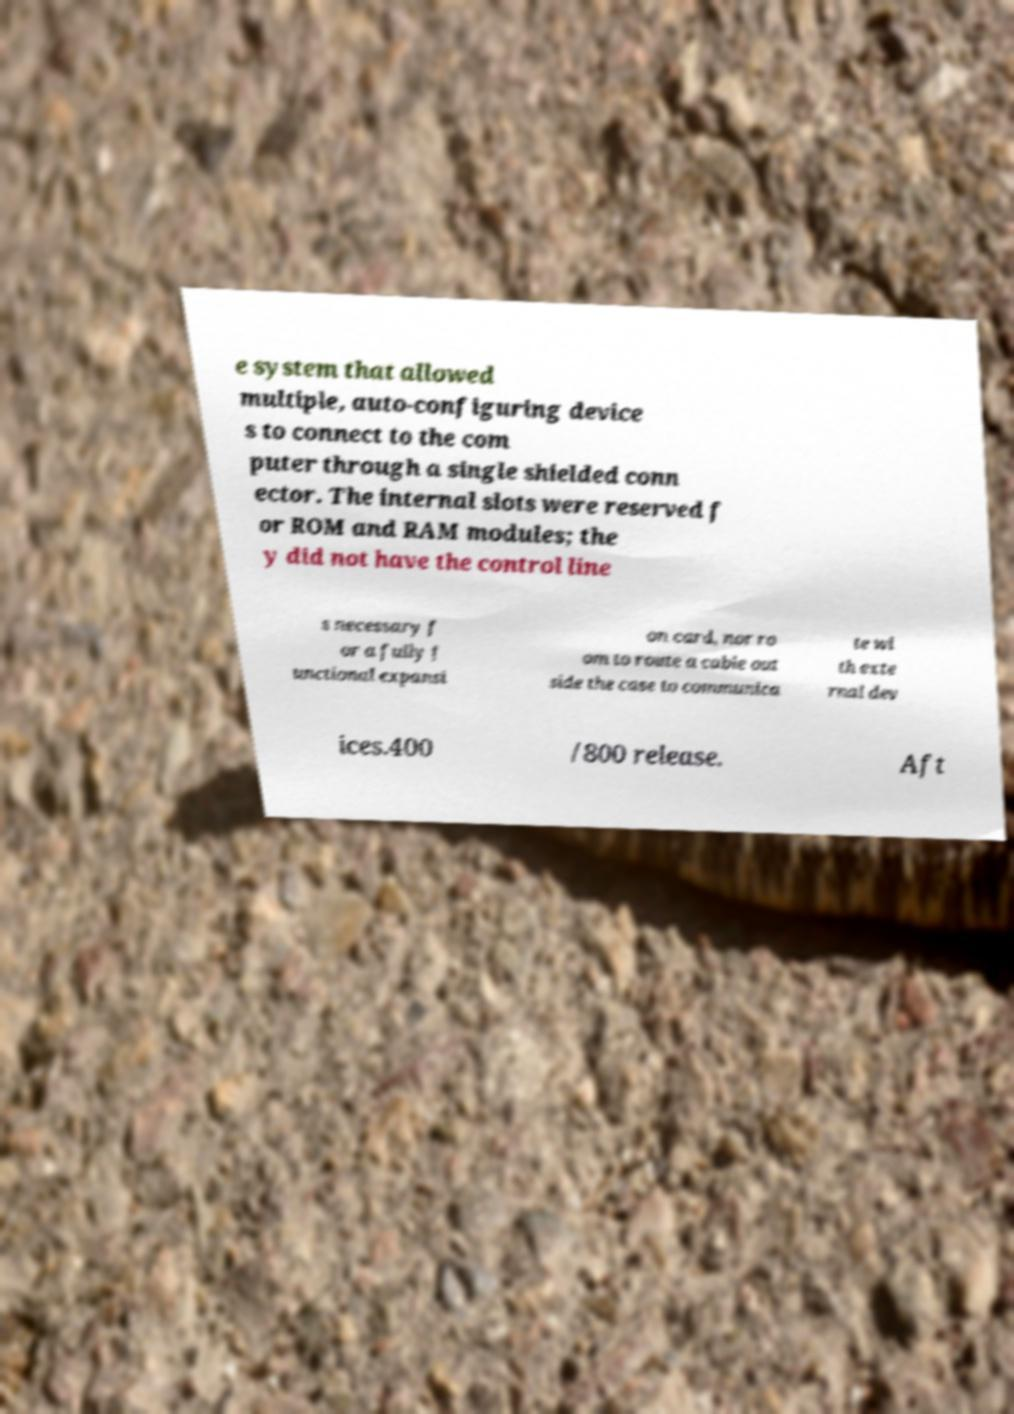Could you assist in decoding the text presented in this image and type it out clearly? e system that allowed multiple, auto-configuring device s to connect to the com puter through a single shielded conn ector. The internal slots were reserved f or ROM and RAM modules; the y did not have the control line s necessary f or a fully f unctional expansi on card, nor ro om to route a cable out side the case to communica te wi th exte rnal dev ices.400 /800 release. Aft 